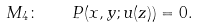Convert formula to latex. <formula><loc_0><loc_0><loc_500><loc_500>M _ { 4 } \colon \quad P ( x , y ; u ( z ) ) = 0 .</formula> 